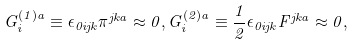Convert formula to latex. <formula><loc_0><loc_0><loc_500><loc_500>G _ { i } ^ { ( 1 ) a } \equiv \epsilon _ { 0 i j k } \pi ^ { j k a } \approx 0 , G _ { i } ^ { ( 2 ) a } \equiv \frac { 1 } { 2 } \epsilon _ { 0 i j k } F ^ { j k a } \approx 0 ,</formula> 